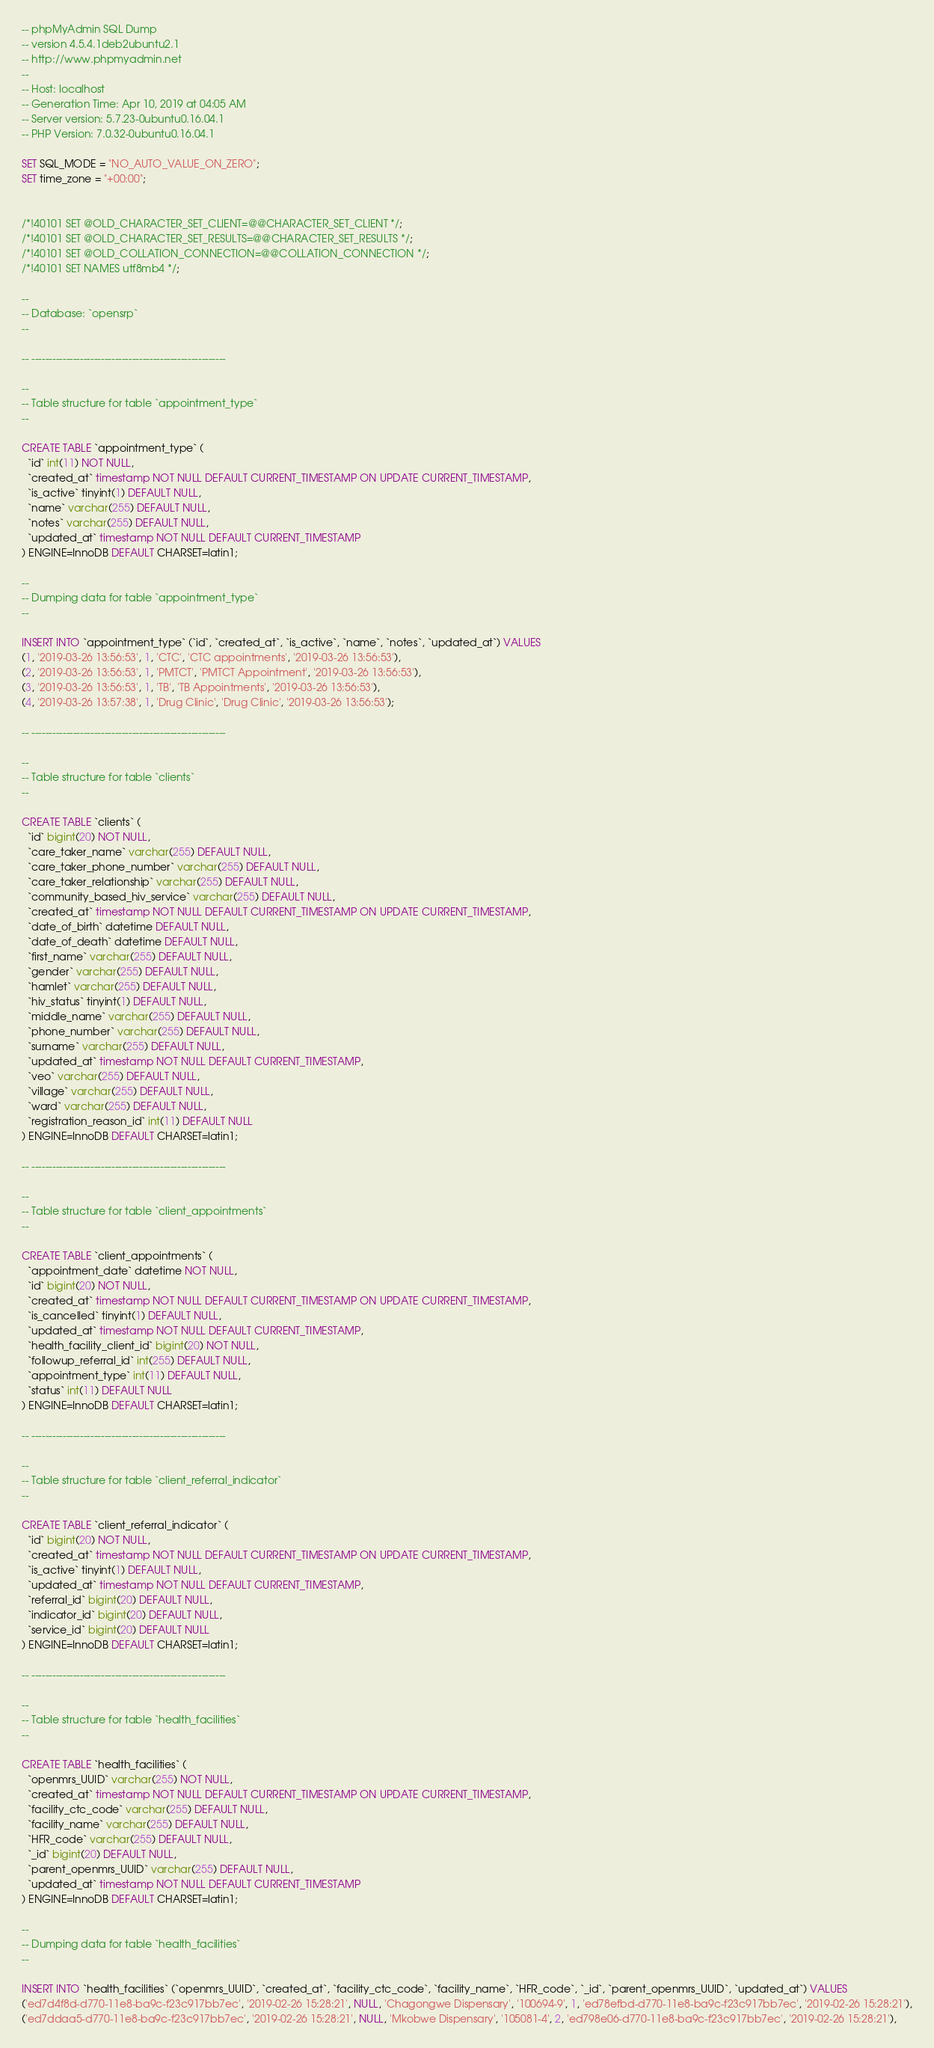<code> <loc_0><loc_0><loc_500><loc_500><_SQL_>-- phpMyAdmin SQL Dump
-- version 4.5.4.1deb2ubuntu2.1
-- http://www.phpmyadmin.net
--
-- Host: localhost
-- Generation Time: Apr 10, 2019 at 04:05 AM
-- Server version: 5.7.23-0ubuntu0.16.04.1
-- PHP Version: 7.0.32-0ubuntu0.16.04.1

SET SQL_MODE = "NO_AUTO_VALUE_ON_ZERO";
SET time_zone = "+00:00";


/*!40101 SET @OLD_CHARACTER_SET_CLIENT=@@CHARACTER_SET_CLIENT */;
/*!40101 SET @OLD_CHARACTER_SET_RESULTS=@@CHARACTER_SET_RESULTS */;
/*!40101 SET @OLD_COLLATION_CONNECTION=@@COLLATION_CONNECTION */;
/*!40101 SET NAMES utf8mb4 */;

--
-- Database: `opensrp`
--

-- --------------------------------------------------------

--
-- Table structure for table `appointment_type`
--

CREATE TABLE `appointment_type` (
  `id` int(11) NOT NULL,
  `created_at` timestamp NOT NULL DEFAULT CURRENT_TIMESTAMP ON UPDATE CURRENT_TIMESTAMP,
  `is_active` tinyint(1) DEFAULT NULL,
  `name` varchar(255) DEFAULT NULL,
  `notes` varchar(255) DEFAULT NULL,
  `updated_at` timestamp NOT NULL DEFAULT CURRENT_TIMESTAMP
) ENGINE=InnoDB DEFAULT CHARSET=latin1;

--
-- Dumping data for table `appointment_type`
--

INSERT INTO `appointment_type` (`id`, `created_at`, `is_active`, `name`, `notes`, `updated_at`) VALUES
(1, '2019-03-26 13:56:53', 1, 'CTC', 'CTC appointments', '2019-03-26 13:56:53'),
(2, '2019-03-26 13:56:53', 1, 'PMTCT', 'PMTCT Appointment', '2019-03-26 13:56:53'),
(3, '2019-03-26 13:56:53', 1, 'TB', 'TB Appointments', '2019-03-26 13:56:53'),
(4, '2019-03-26 13:57:38', 1, 'Drug Clinic', 'Drug Clinic', '2019-03-26 13:56:53');

-- --------------------------------------------------------

--
-- Table structure for table `clients`
--

CREATE TABLE `clients` (
  `id` bigint(20) NOT NULL,
  `care_taker_name` varchar(255) DEFAULT NULL,
  `care_taker_phone_number` varchar(255) DEFAULT NULL,
  `care_taker_relationship` varchar(255) DEFAULT NULL,
  `community_based_hiv_service` varchar(255) DEFAULT NULL,
  `created_at` timestamp NOT NULL DEFAULT CURRENT_TIMESTAMP ON UPDATE CURRENT_TIMESTAMP,
  `date_of_birth` datetime DEFAULT NULL,
  `date_of_death` datetime DEFAULT NULL,
  `first_name` varchar(255) DEFAULT NULL,
  `gender` varchar(255) DEFAULT NULL,
  `hamlet` varchar(255) DEFAULT NULL,
  `hiv_status` tinyint(1) DEFAULT NULL,
  `middle_name` varchar(255) DEFAULT NULL,
  `phone_number` varchar(255) DEFAULT NULL,
  `surname` varchar(255) DEFAULT NULL,
  `updated_at` timestamp NOT NULL DEFAULT CURRENT_TIMESTAMP,
  `veo` varchar(255) DEFAULT NULL,
  `village` varchar(255) DEFAULT NULL,
  `ward` varchar(255) DEFAULT NULL,
  `registration_reason_id` int(11) DEFAULT NULL
) ENGINE=InnoDB DEFAULT CHARSET=latin1;

-- --------------------------------------------------------

--
-- Table structure for table `client_appointments`
--

CREATE TABLE `client_appointments` (
  `appointment_date` datetime NOT NULL,
  `id` bigint(20) NOT NULL,
  `created_at` timestamp NOT NULL DEFAULT CURRENT_TIMESTAMP ON UPDATE CURRENT_TIMESTAMP,
  `is_cancelled` tinyint(1) DEFAULT NULL,
  `updated_at` timestamp NOT NULL DEFAULT CURRENT_TIMESTAMP,
  `health_facility_client_id` bigint(20) NOT NULL,
  `followup_referral_id` int(255) DEFAULT NULL,
  `appointment_type` int(11) DEFAULT NULL,
  `status` int(11) DEFAULT NULL
) ENGINE=InnoDB DEFAULT CHARSET=latin1;

-- --------------------------------------------------------

--
-- Table structure for table `client_referral_indicator`
--

CREATE TABLE `client_referral_indicator` (
  `id` bigint(20) NOT NULL,
  `created_at` timestamp NOT NULL DEFAULT CURRENT_TIMESTAMP ON UPDATE CURRENT_TIMESTAMP,
  `is_active` tinyint(1) DEFAULT NULL,
  `updated_at` timestamp NOT NULL DEFAULT CURRENT_TIMESTAMP,
  `referral_id` bigint(20) DEFAULT NULL,
  `indicator_id` bigint(20) DEFAULT NULL,
  `service_id` bigint(20) DEFAULT NULL
) ENGINE=InnoDB DEFAULT CHARSET=latin1;

-- --------------------------------------------------------

--
-- Table structure for table `health_facilities`
--

CREATE TABLE `health_facilities` (
  `openmrs_UUID` varchar(255) NOT NULL,
  `created_at` timestamp NOT NULL DEFAULT CURRENT_TIMESTAMP ON UPDATE CURRENT_TIMESTAMP,
  `facility_ctc_code` varchar(255) DEFAULT NULL,
  `facility_name` varchar(255) DEFAULT NULL,
  `HFR_code` varchar(255) DEFAULT NULL,
  `_id` bigint(20) DEFAULT NULL,
  `parent_openmrs_UUID` varchar(255) DEFAULT NULL,
  `updated_at` timestamp NOT NULL DEFAULT CURRENT_TIMESTAMP
) ENGINE=InnoDB DEFAULT CHARSET=latin1;

--
-- Dumping data for table `health_facilities`
--

INSERT INTO `health_facilities` (`openmrs_UUID`, `created_at`, `facility_ctc_code`, `facility_name`, `HFR_code`, `_id`, `parent_openmrs_UUID`, `updated_at`) VALUES
('ed7d4f8d-d770-11e8-ba9c-f23c917bb7ec', '2019-02-26 15:28:21', NULL, 'Chagongwe Dispensary', '100694-9', 1, 'ed78efbd-d770-11e8-ba9c-f23c917bb7ec', '2019-02-26 15:28:21'),
('ed7ddaa5-d770-11e8-ba9c-f23c917bb7ec', '2019-02-26 15:28:21', NULL, 'Mkobwe Dispensary', '105081-4', 2, 'ed798e06-d770-11e8-ba9c-f23c917bb7ec', '2019-02-26 15:28:21'),</code> 